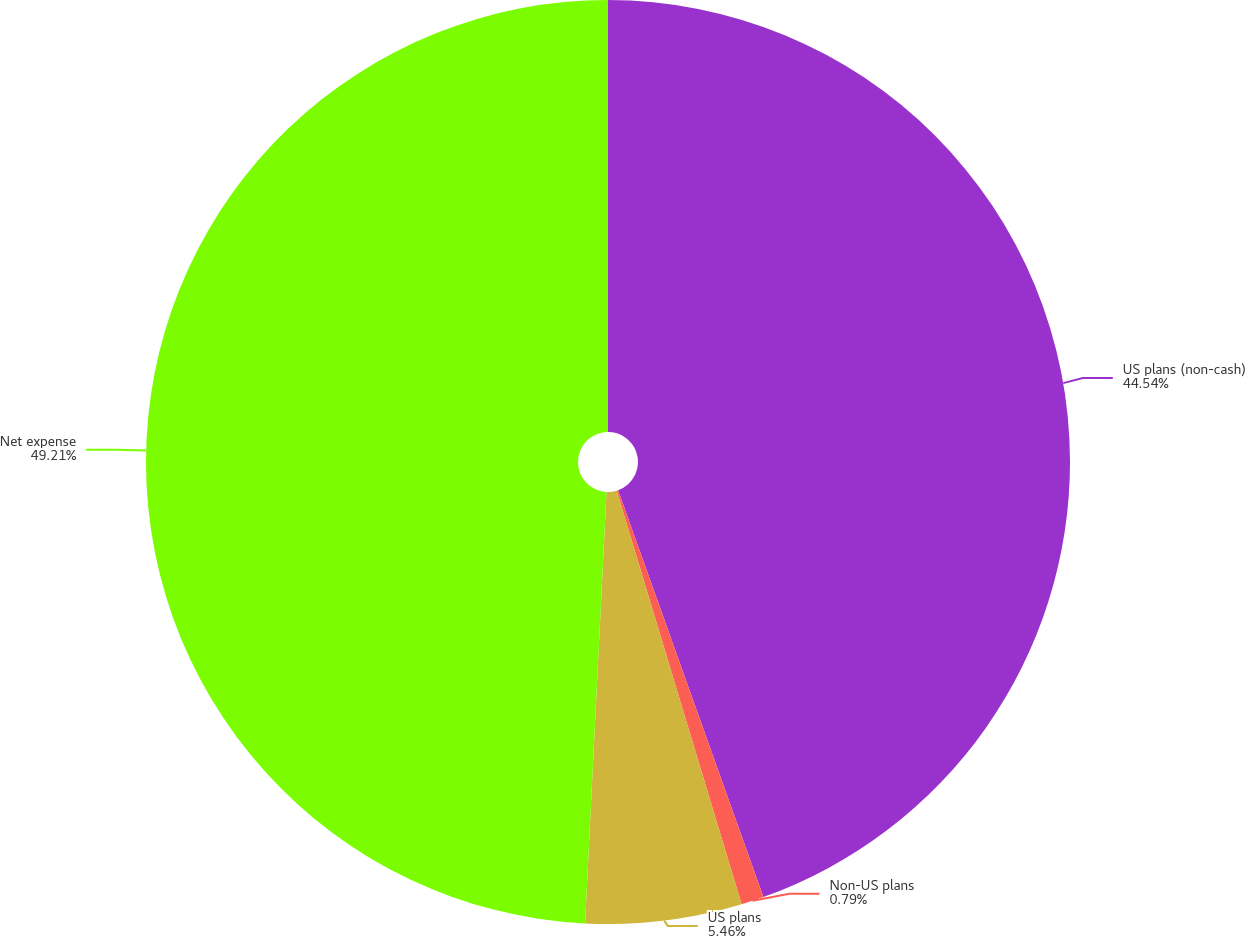<chart> <loc_0><loc_0><loc_500><loc_500><pie_chart><fcel>US plans (non-cash)<fcel>Non-US plans<fcel>US plans<fcel>Net expense<nl><fcel>44.54%<fcel>0.79%<fcel>5.46%<fcel>49.21%<nl></chart> 